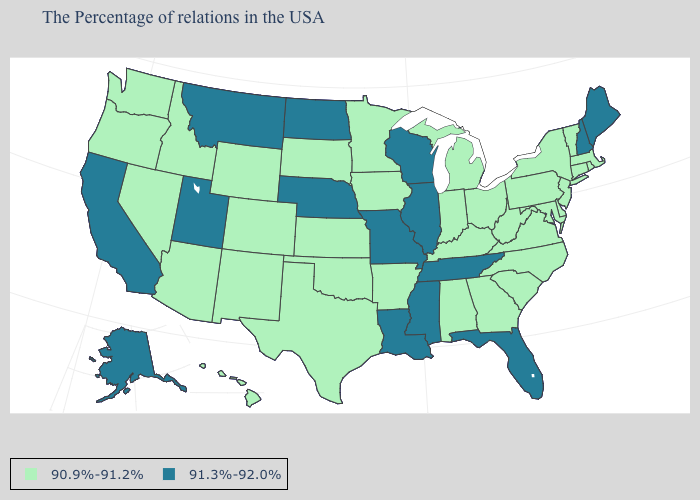What is the value of Illinois?
Write a very short answer. 91.3%-92.0%. Name the states that have a value in the range 91.3%-92.0%?
Write a very short answer. Maine, New Hampshire, Florida, Tennessee, Wisconsin, Illinois, Mississippi, Louisiana, Missouri, Nebraska, North Dakota, Utah, Montana, California, Alaska. Does the first symbol in the legend represent the smallest category?
Answer briefly. Yes. Which states have the highest value in the USA?
Write a very short answer. Maine, New Hampshire, Florida, Tennessee, Wisconsin, Illinois, Mississippi, Louisiana, Missouri, Nebraska, North Dakota, Utah, Montana, California, Alaska. What is the value of Nevada?
Concise answer only. 90.9%-91.2%. What is the highest value in the Northeast ?
Short answer required. 91.3%-92.0%. What is the value of Mississippi?
Short answer required. 91.3%-92.0%. Which states have the lowest value in the West?
Keep it brief. Wyoming, Colorado, New Mexico, Arizona, Idaho, Nevada, Washington, Oregon, Hawaii. Name the states that have a value in the range 91.3%-92.0%?
Write a very short answer. Maine, New Hampshire, Florida, Tennessee, Wisconsin, Illinois, Mississippi, Louisiana, Missouri, Nebraska, North Dakota, Utah, Montana, California, Alaska. What is the value of Idaho?
Be succinct. 90.9%-91.2%. What is the highest value in the Northeast ?
Write a very short answer. 91.3%-92.0%. Name the states that have a value in the range 90.9%-91.2%?
Give a very brief answer. Massachusetts, Rhode Island, Vermont, Connecticut, New York, New Jersey, Delaware, Maryland, Pennsylvania, Virginia, North Carolina, South Carolina, West Virginia, Ohio, Georgia, Michigan, Kentucky, Indiana, Alabama, Arkansas, Minnesota, Iowa, Kansas, Oklahoma, Texas, South Dakota, Wyoming, Colorado, New Mexico, Arizona, Idaho, Nevada, Washington, Oregon, Hawaii. What is the highest value in states that border Idaho?
Write a very short answer. 91.3%-92.0%. Does Missouri have a lower value than Connecticut?
Answer briefly. No. Among the states that border New Mexico , does Utah have the highest value?
Write a very short answer. Yes. 